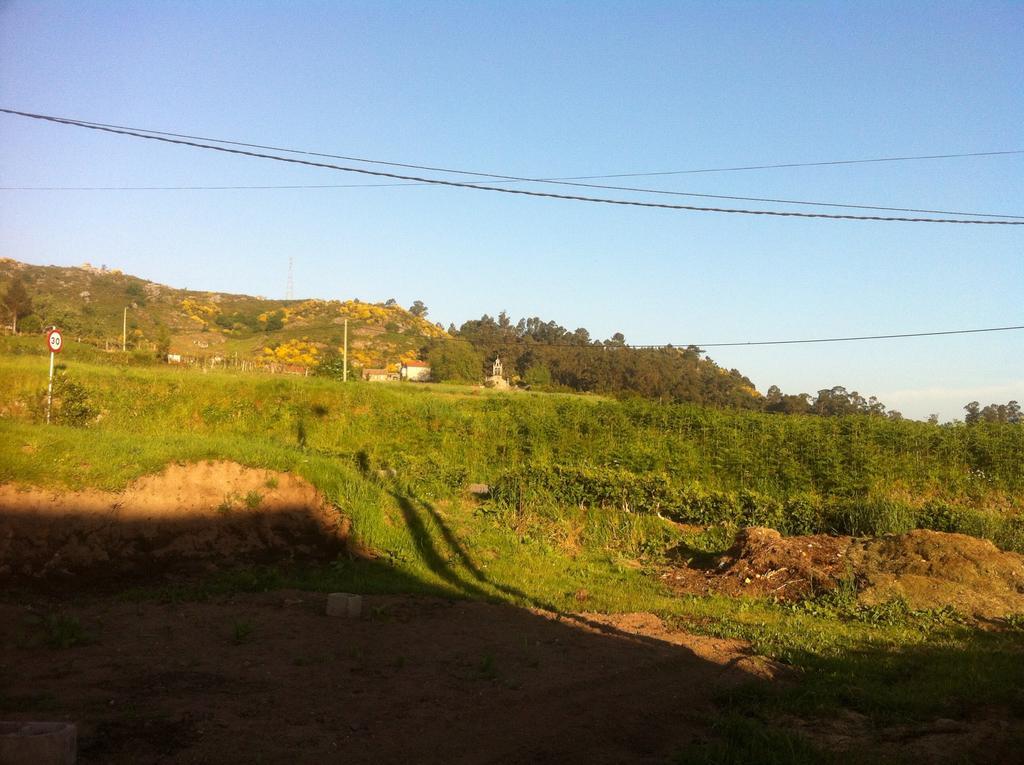Please provide a concise description of this image. In this image we can see there is a grass on the ground. In the background, we can see there are trees, mountains and sky. 